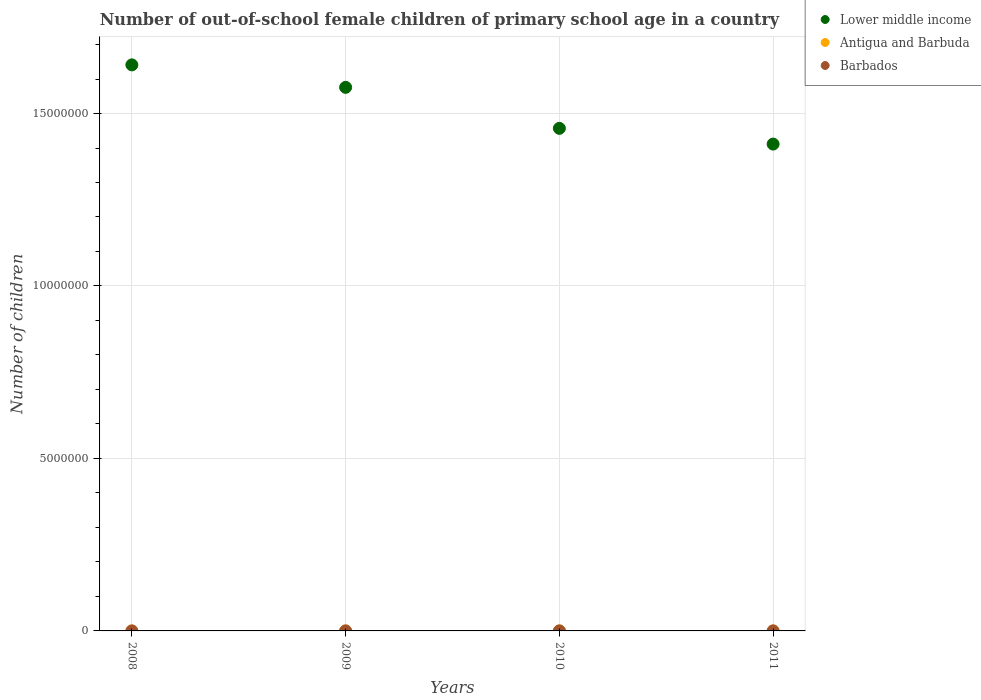What is the number of out-of-school female children in Barbados in 2010?
Offer a terse response. 294. Across all years, what is the maximum number of out-of-school female children in Antigua and Barbuda?
Your answer should be compact. 773. Across all years, what is the minimum number of out-of-school female children in Lower middle income?
Ensure brevity in your answer.  1.41e+07. In which year was the number of out-of-school female children in Lower middle income maximum?
Ensure brevity in your answer.  2008. In which year was the number of out-of-school female children in Antigua and Barbuda minimum?
Give a very brief answer. 2008. What is the total number of out-of-school female children in Antigua and Barbuda in the graph?
Your answer should be compact. 2413. What is the difference between the number of out-of-school female children in Lower middle income in 2009 and that in 2010?
Your answer should be very brief. 1.19e+06. What is the difference between the number of out-of-school female children in Antigua and Barbuda in 2008 and the number of out-of-school female children in Lower middle income in 2010?
Provide a succinct answer. -1.46e+07. What is the average number of out-of-school female children in Antigua and Barbuda per year?
Offer a very short reply. 603.25. In the year 2009, what is the difference between the number of out-of-school female children in Lower middle income and number of out-of-school female children in Antigua and Barbuda?
Your answer should be very brief. 1.58e+07. What is the ratio of the number of out-of-school female children in Barbados in 2010 to that in 2011?
Offer a terse response. 0.89. Is the number of out-of-school female children in Barbados in 2009 less than that in 2010?
Your answer should be very brief. No. What is the difference between the highest and the second highest number of out-of-school female children in Antigua and Barbuda?
Offer a terse response. 19. What is the difference between the highest and the lowest number of out-of-school female children in Lower middle income?
Ensure brevity in your answer.  2.30e+06. In how many years, is the number of out-of-school female children in Lower middle income greater than the average number of out-of-school female children in Lower middle income taken over all years?
Provide a succinct answer. 2. Is the sum of the number of out-of-school female children in Lower middle income in 2008 and 2011 greater than the maximum number of out-of-school female children in Barbados across all years?
Ensure brevity in your answer.  Yes. Is the number of out-of-school female children in Barbados strictly less than the number of out-of-school female children in Antigua and Barbuda over the years?
Provide a short and direct response. Yes. How many years are there in the graph?
Your answer should be compact. 4. How many legend labels are there?
Your response must be concise. 3. What is the title of the graph?
Keep it short and to the point. Number of out-of-school female children of primary school age in a country. What is the label or title of the Y-axis?
Your response must be concise. Number of children. What is the Number of children of Lower middle income in 2008?
Your answer should be very brief. 1.64e+07. What is the Number of children in Antigua and Barbuda in 2008?
Your response must be concise. 392. What is the Number of children in Barbados in 2008?
Provide a short and direct response. 219. What is the Number of children of Lower middle income in 2009?
Your response must be concise. 1.58e+07. What is the Number of children in Antigua and Barbuda in 2009?
Your response must be concise. 494. What is the Number of children in Barbados in 2009?
Provide a short and direct response. 361. What is the Number of children of Lower middle income in 2010?
Give a very brief answer. 1.46e+07. What is the Number of children in Antigua and Barbuda in 2010?
Offer a very short reply. 754. What is the Number of children of Barbados in 2010?
Ensure brevity in your answer.  294. What is the Number of children of Lower middle income in 2011?
Ensure brevity in your answer.  1.41e+07. What is the Number of children in Antigua and Barbuda in 2011?
Provide a succinct answer. 773. What is the Number of children in Barbados in 2011?
Give a very brief answer. 331. Across all years, what is the maximum Number of children of Lower middle income?
Provide a succinct answer. 1.64e+07. Across all years, what is the maximum Number of children in Antigua and Barbuda?
Offer a terse response. 773. Across all years, what is the maximum Number of children in Barbados?
Provide a short and direct response. 361. Across all years, what is the minimum Number of children in Lower middle income?
Ensure brevity in your answer.  1.41e+07. Across all years, what is the minimum Number of children in Antigua and Barbuda?
Make the answer very short. 392. Across all years, what is the minimum Number of children in Barbados?
Offer a terse response. 219. What is the total Number of children of Lower middle income in the graph?
Offer a very short reply. 6.09e+07. What is the total Number of children in Antigua and Barbuda in the graph?
Offer a very short reply. 2413. What is the total Number of children of Barbados in the graph?
Keep it short and to the point. 1205. What is the difference between the Number of children of Lower middle income in 2008 and that in 2009?
Your response must be concise. 6.51e+05. What is the difference between the Number of children of Antigua and Barbuda in 2008 and that in 2009?
Your answer should be compact. -102. What is the difference between the Number of children of Barbados in 2008 and that in 2009?
Make the answer very short. -142. What is the difference between the Number of children in Lower middle income in 2008 and that in 2010?
Your answer should be compact. 1.84e+06. What is the difference between the Number of children of Antigua and Barbuda in 2008 and that in 2010?
Provide a succinct answer. -362. What is the difference between the Number of children of Barbados in 2008 and that in 2010?
Keep it short and to the point. -75. What is the difference between the Number of children in Lower middle income in 2008 and that in 2011?
Your answer should be very brief. 2.30e+06. What is the difference between the Number of children of Antigua and Barbuda in 2008 and that in 2011?
Provide a short and direct response. -381. What is the difference between the Number of children in Barbados in 2008 and that in 2011?
Provide a succinct answer. -112. What is the difference between the Number of children in Lower middle income in 2009 and that in 2010?
Provide a succinct answer. 1.19e+06. What is the difference between the Number of children in Antigua and Barbuda in 2009 and that in 2010?
Your answer should be very brief. -260. What is the difference between the Number of children in Lower middle income in 2009 and that in 2011?
Your answer should be very brief. 1.64e+06. What is the difference between the Number of children of Antigua and Barbuda in 2009 and that in 2011?
Provide a short and direct response. -279. What is the difference between the Number of children in Barbados in 2009 and that in 2011?
Offer a terse response. 30. What is the difference between the Number of children in Lower middle income in 2010 and that in 2011?
Offer a terse response. 4.56e+05. What is the difference between the Number of children in Antigua and Barbuda in 2010 and that in 2011?
Your answer should be compact. -19. What is the difference between the Number of children of Barbados in 2010 and that in 2011?
Offer a very short reply. -37. What is the difference between the Number of children in Lower middle income in 2008 and the Number of children in Antigua and Barbuda in 2009?
Ensure brevity in your answer.  1.64e+07. What is the difference between the Number of children of Lower middle income in 2008 and the Number of children of Barbados in 2009?
Ensure brevity in your answer.  1.64e+07. What is the difference between the Number of children of Lower middle income in 2008 and the Number of children of Antigua and Barbuda in 2010?
Provide a succinct answer. 1.64e+07. What is the difference between the Number of children of Lower middle income in 2008 and the Number of children of Barbados in 2010?
Offer a terse response. 1.64e+07. What is the difference between the Number of children in Lower middle income in 2008 and the Number of children in Antigua and Barbuda in 2011?
Provide a succinct answer. 1.64e+07. What is the difference between the Number of children of Lower middle income in 2008 and the Number of children of Barbados in 2011?
Provide a succinct answer. 1.64e+07. What is the difference between the Number of children in Lower middle income in 2009 and the Number of children in Antigua and Barbuda in 2010?
Make the answer very short. 1.58e+07. What is the difference between the Number of children of Lower middle income in 2009 and the Number of children of Barbados in 2010?
Your answer should be compact. 1.58e+07. What is the difference between the Number of children in Lower middle income in 2009 and the Number of children in Antigua and Barbuda in 2011?
Your answer should be compact. 1.58e+07. What is the difference between the Number of children in Lower middle income in 2009 and the Number of children in Barbados in 2011?
Give a very brief answer. 1.58e+07. What is the difference between the Number of children in Antigua and Barbuda in 2009 and the Number of children in Barbados in 2011?
Provide a short and direct response. 163. What is the difference between the Number of children of Lower middle income in 2010 and the Number of children of Antigua and Barbuda in 2011?
Provide a short and direct response. 1.46e+07. What is the difference between the Number of children of Lower middle income in 2010 and the Number of children of Barbados in 2011?
Offer a very short reply. 1.46e+07. What is the difference between the Number of children of Antigua and Barbuda in 2010 and the Number of children of Barbados in 2011?
Ensure brevity in your answer.  423. What is the average Number of children of Lower middle income per year?
Provide a short and direct response. 1.52e+07. What is the average Number of children of Antigua and Barbuda per year?
Your answer should be compact. 603.25. What is the average Number of children in Barbados per year?
Provide a succinct answer. 301.25. In the year 2008, what is the difference between the Number of children in Lower middle income and Number of children in Antigua and Barbuda?
Your answer should be compact. 1.64e+07. In the year 2008, what is the difference between the Number of children of Lower middle income and Number of children of Barbados?
Your answer should be very brief. 1.64e+07. In the year 2008, what is the difference between the Number of children in Antigua and Barbuda and Number of children in Barbados?
Keep it short and to the point. 173. In the year 2009, what is the difference between the Number of children in Lower middle income and Number of children in Antigua and Barbuda?
Offer a terse response. 1.58e+07. In the year 2009, what is the difference between the Number of children in Lower middle income and Number of children in Barbados?
Offer a very short reply. 1.58e+07. In the year 2009, what is the difference between the Number of children in Antigua and Barbuda and Number of children in Barbados?
Provide a short and direct response. 133. In the year 2010, what is the difference between the Number of children in Lower middle income and Number of children in Antigua and Barbuda?
Offer a very short reply. 1.46e+07. In the year 2010, what is the difference between the Number of children of Lower middle income and Number of children of Barbados?
Your response must be concise. 1.46e+07. In the year 2010, what is the difference between the Number of children of Antigua and Barbuda and Number of children of Barbados?
Offer a very short reply. 460. In the year 2011, what is the difference between the Number of children in Lower middle income and Number of children in Antigua and Barbuda?
Your answer should be very brief. 1.41e+07. In the year 2011, what is the difference between the Number of children in Lower middle income and Number of children in Barbados?
Provide a short and direct response. 1.41e+07. In the year 2011, what is the difference between the Number of children in Antigua and Barbuda and Number of children in Barbados?
Your answer should be very brief. 442. What is the ratio of the Number of children in Lower middle income in 2008 to that in 2009?
Ensure brevity in your answer.  1.04. What is the ratio of the Number of children of Antigua and Barbuda in 2008 to that in 2009?
Offer a terse response. 0.79. What is the ratio of the Number of children of Barbados in 2008 to that in 2009?
Keep it short and to the point. 0.61. What is the ratio of the Number of children in Lower middle income in 2008 to that in 2010?
Provide a succinct answer. 1.13. What is the ratio of the Number of children in Antigua and Barbuda in 2008 to that in 2010?
Provide a succinct answer. 0.52. What is the ratio of the Number of children in Barbados in 2008 to that in 2010?
Give a very brief answer. 0.74. What is the ratio of the Number of children in Lower middle income in 2008 to that in 2011?
Make the answer very short. 1.16. What is the ratio of the Number of children in Antigua and Barbuda in 2008 to that in 2011?
Provide a succinct answer. 0.51. What is the ratio of the Number of children of Barbados in 2008 to that in 2011?
Offer a very short reply. 0.66. What is the ratio of the Number of children in Lower middle income in 2009 to that in 2010?
Offer a terse response. 1.08. What is the ratio of the Number of children in Antigua and Barbuda in 2009 to that in 2010?
Your response must be concise. 0.66. What is the ratio of the Number of children of Barbados in 2009 to that in 2010?
Give a very brief answer. 1.23. What is the ratio of the Number of children of Lower middle income in 2009 to that in 2011?
Your answer should be compact. 1.12. What is the ratio of the Number of children in Antigua and Barbuda in 2009 to that in 2011?
Provide a succinct answer. 0.64. What is the ratio of the Number of children in Barbados in 2009 to that in 2011?
Keep it short and to the point. 1.09. What is the ratio of the Number of children of Lower middle income in 2010 to that in 2011?
Give a very brief answer. 1.03. What is the ratio of the Number of children of Antigua and Barbuda in 2010 to that in 2011?
Offer a terse response. 0.98. What is the ratio of the Number of children in Barbados in 2010 to that in 2011?
Your response must be concise. 0.89. What is the difference between the highest and the second highest Number of children in Lower middle income?
Make the answer very short. 6.51e+05. What is the difference between the highest and the second highest Number of children in Antigua and Barbuda?
Provide a succinct answer. 19. What is the difference between the highest and the lowest Number of children of Lower middle income?
Your answer should be compact. 2.30e+06. What is the difference between the highest and the lowest Number of children of Antigua and Barbuda?
Ensure brevity in your answer.  381. What is the difference between the highest and the lowest Number of children of Barbados?
Give a very brief answer. 142. 